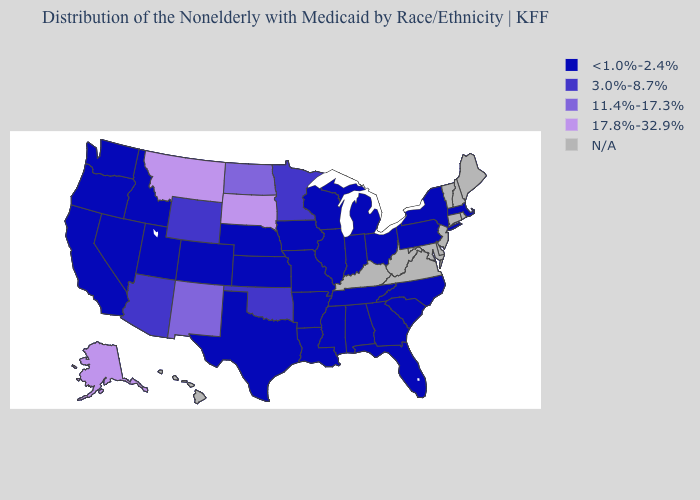Name the states that have a value in the range N/A?
Quick response, please. Connecticut, Delaware, Hawaii, Kentucky, Maine, Maryland, New Hampshire, New Jersey, Rhode Island, Vermont, Virginia, West Virginia. What is the lowest value in the Northeast?
Write a very short answer. <1.0%-2.4%. Name the states that have a value in the range N/A?
Answer briefly. Connecticut, Delaware, Hawaii, Kentucky, Maine, Maryland, New Hampshire, New Jersey, Rhode Island, Vermont, Virginia, West Virginia. Name the states that have a value in the range N/A?
Answer briefly. Connecticut, Delaware, Hawaii, Kentucky, Maine, Maryland, New Hampshire, New Jersey, Rhode Island, Vermont, Virginia, West Virginia. What is the value of Rhode Island?
Give a very brief answer. N/A. Does South Dakota have the highest value in the USA?
Short answer required. Yes. What is the value of Ohio?
Keep it brief. <1.0%-2.4%. What is the value of Oregon?
Give a very brief answer. <1.0%-2.4%. Does North Dakota have the lowest value in the USA?
Answer briefly. No. Name the states that have a value in the range 3.0%-8.7%?
Keep it brief. Arizona, Minnesota, Oklahoma, Wyoming. Does Missouri have the lowest value in the USA?
Short answer required. Yes. What is the highest value in the Northeast ?
Be succinct. <1.0%-2.4%. 